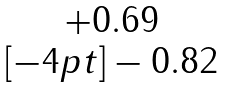<formula> <loc_0><loc_0><loc_500><loc_500>\begin{matrix} + 0 . 6 9 \\ [ - 4 p t ] - 0 . 8 2 \end{matrix}</formula> 